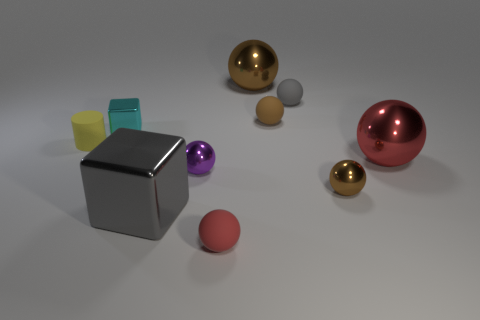What is the shape of the red thing behind the big gray metal cube? sphere 